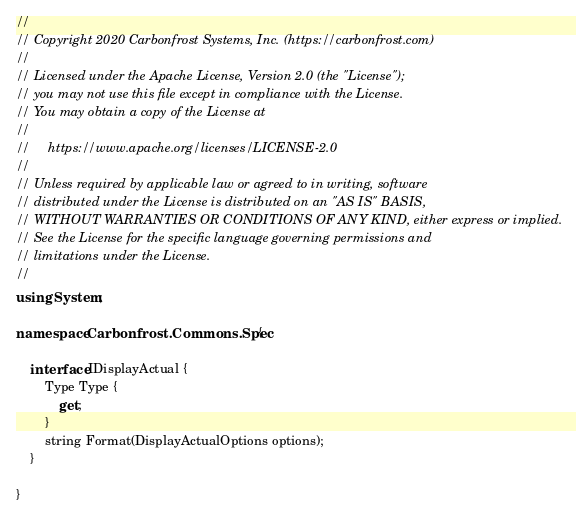Convert code to text. <code><loc_0><loc_0><loc_500><loc_500><_C#_>//
// Copyright 2020 Carbonfrost Systems, Inc. (https://carbonfrost.com)
//
// Licensed under the Apache License, Version 2.0 (the "License");
// you may not use this file except in compliance with the License.
// You may obtain a copy of the License at
//
//     https://www.apache.org/licenses/LICENSE-2.0
//
// Unless required by applicable law or agreed to in writing, software
// distributed under the License is distributed on an "AS IS" BASIS,
// WITHOUT WARRANTIES OR CONDITIONS OF ANY KIND, either express or implied.
// See the License for the specific language governing permissions and
// limitations under the License.
//
using System;

namespace Carbonfrost.Commons.Spec {

    interface IDisplayActual {
        Type Type {
            get;
        }
        string Format(DisplayActualOptions options);
    }

}
</code> 